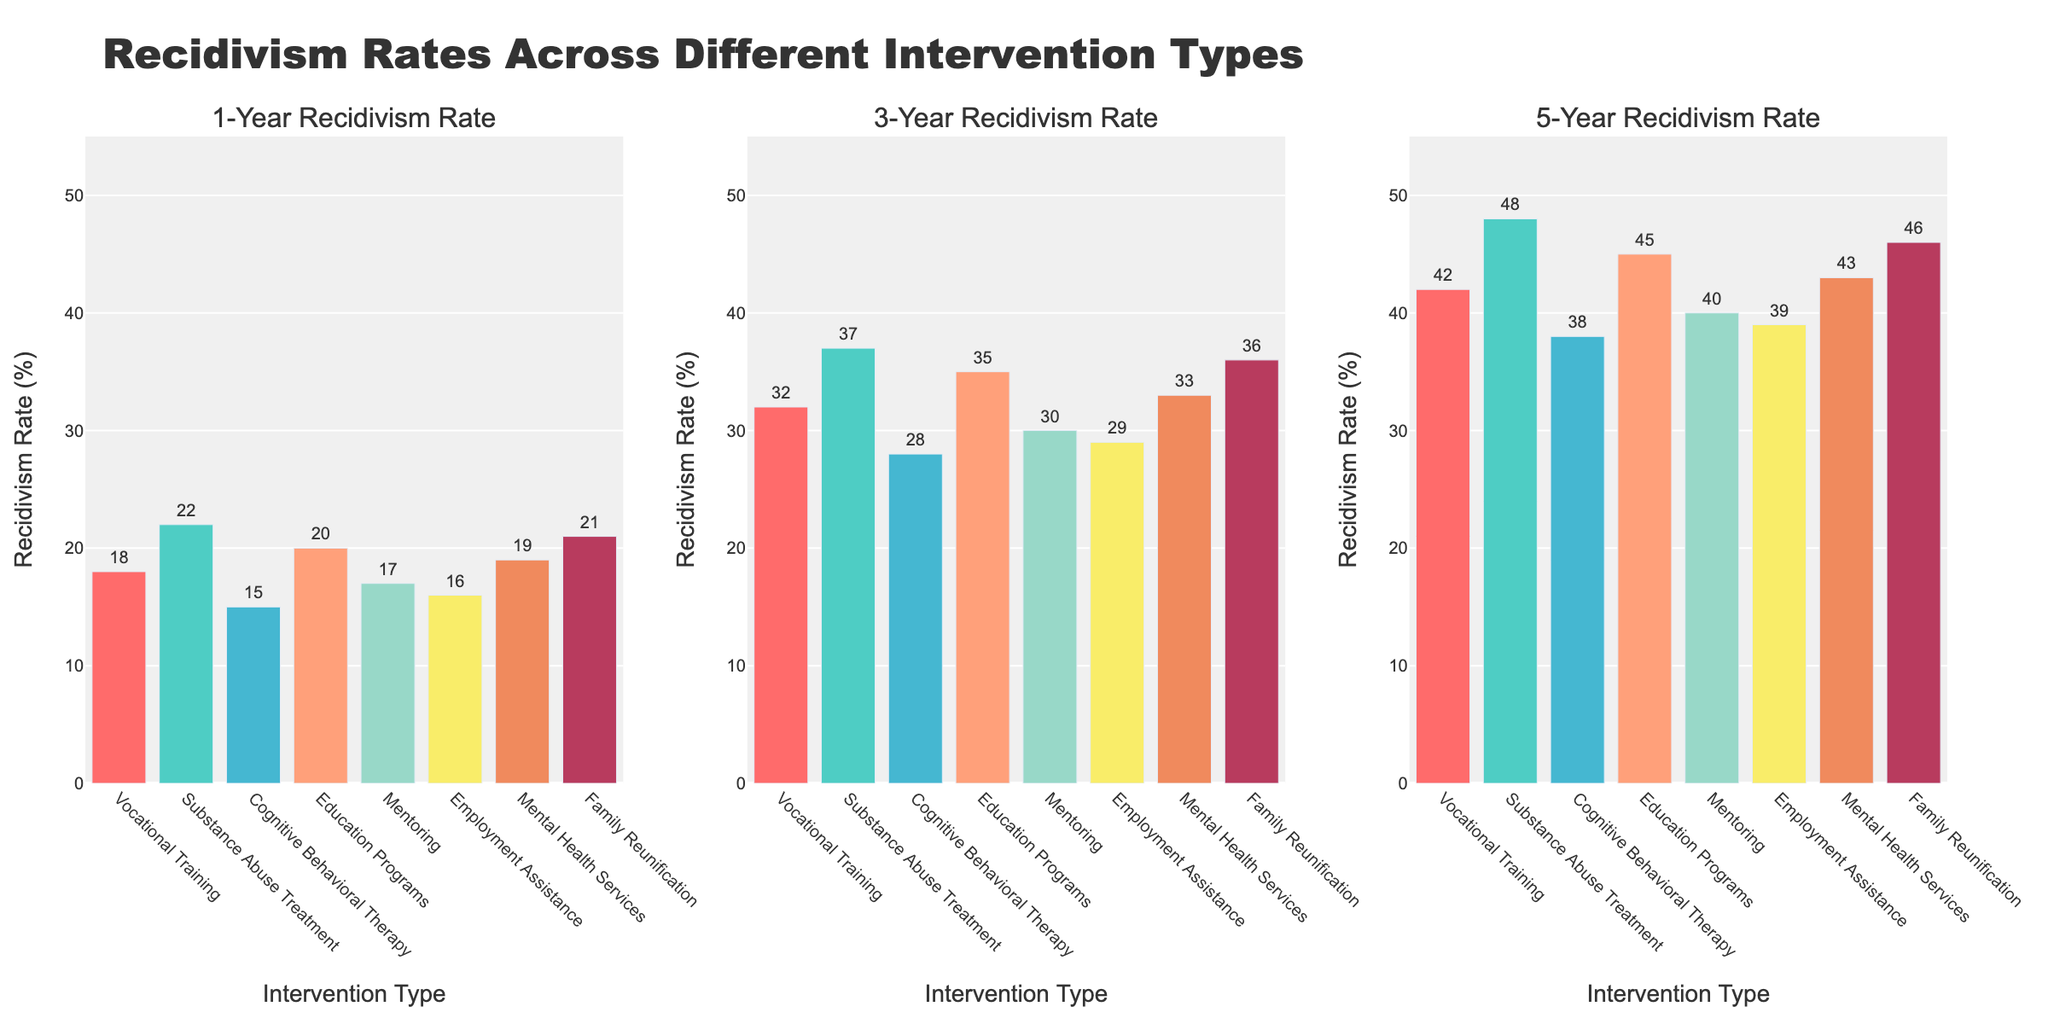What is the title of the plot? The title is displayed at the top of the figure and reads "Recidivism Rates Across Different Intervention Types".
Answer: "Recidivism Rates Across Different Intervention Types" Which intervention type has the lowest 1-Year Recidivism Rate? By looking at the first subplot for 1-Year Recidivism Rate, we see that Cognitive Behavioral Therapy has the lowest value with a rate of 15%.
Answer: Cognitive Behavioral Therapy How does the 5-Year Recidivism Rate of Mental Health Services compare to that of Employment Assistance? In the third subplot showing 5-Year Recidivism Rates, Mental Health Services have a rate of 43%, while Employment Assistance has a rate of 39%. Therefore, Mental Health Services have a higher 5-Year Recidivism Rate by 4 percentage points.
Answer: Mental Health Services have 4% higher 5-Year Recidivism Rate What is the difference between the highest and lowest 3-Year Recidivism Rates? The highest 3-Year Recidivism Rate is for Substance Abuse Treatment (37%) and the lowest is for Cognitive Behavioral Therapy (28%), leading to a difference of 37% - 28% = 9%.
Answer: 9% What is the average 1-Year Recidivism Rate across all intervention types? Adding the 1-Year Recidivism Rates: 18 + 22 + 15 + 20 + 17 + 16 + 19 + 21 = 148. Dividing by the 8 intervention types gives 148/8 = 18.5.
Answer: 18.5% How much higher is the 5-Year Recidivism Rate for Substance Abuse Treatment compared to Vocational Training? The 5-Year Recidivism Rate for Substance Abuse Treatment is 48% while for Vocational Training it is 42%. The difference is 48% - 42% = 6%.
Answer: 6% higher What is the trend in recidivism rates over time for Mentoring? Analyzing the rates for Mentoring: 1-Year (17%), 3-Year (30%), 5-Year (40%), we observe that the recidivism rates increase over time.
Answer: Increasing Which intervention type shows the most significant increase in recidivism rate from 1 Year to 5 Years? The highest increase can be computed by examining the change for each type. Substance Abuse Treatment has significant increases from 22% (1-Year) to 48% (5-Year), observing an increase of 26 percentage points, which is the greatest among all.
Answer: Substance Abuse Treatment How many intervention types have a 5-Year Recidivism Rate greater than 40%? By examining the third subplot, we observe that five intervention types (Vocational Training, Substance Abuse Treatment, Education Programs, Mental Health Services, Family Reunification) exceed the 40% rate.
Answer: 5 What is the combined 3-Year Recidivism Rate of Employment Assistance and Mentoring? Adding the 3-Year Recidivism Rates for Employment Assistance (29%) and Mentoring (30%) gives 29% + 30% = 59%.
Answer: 59% 